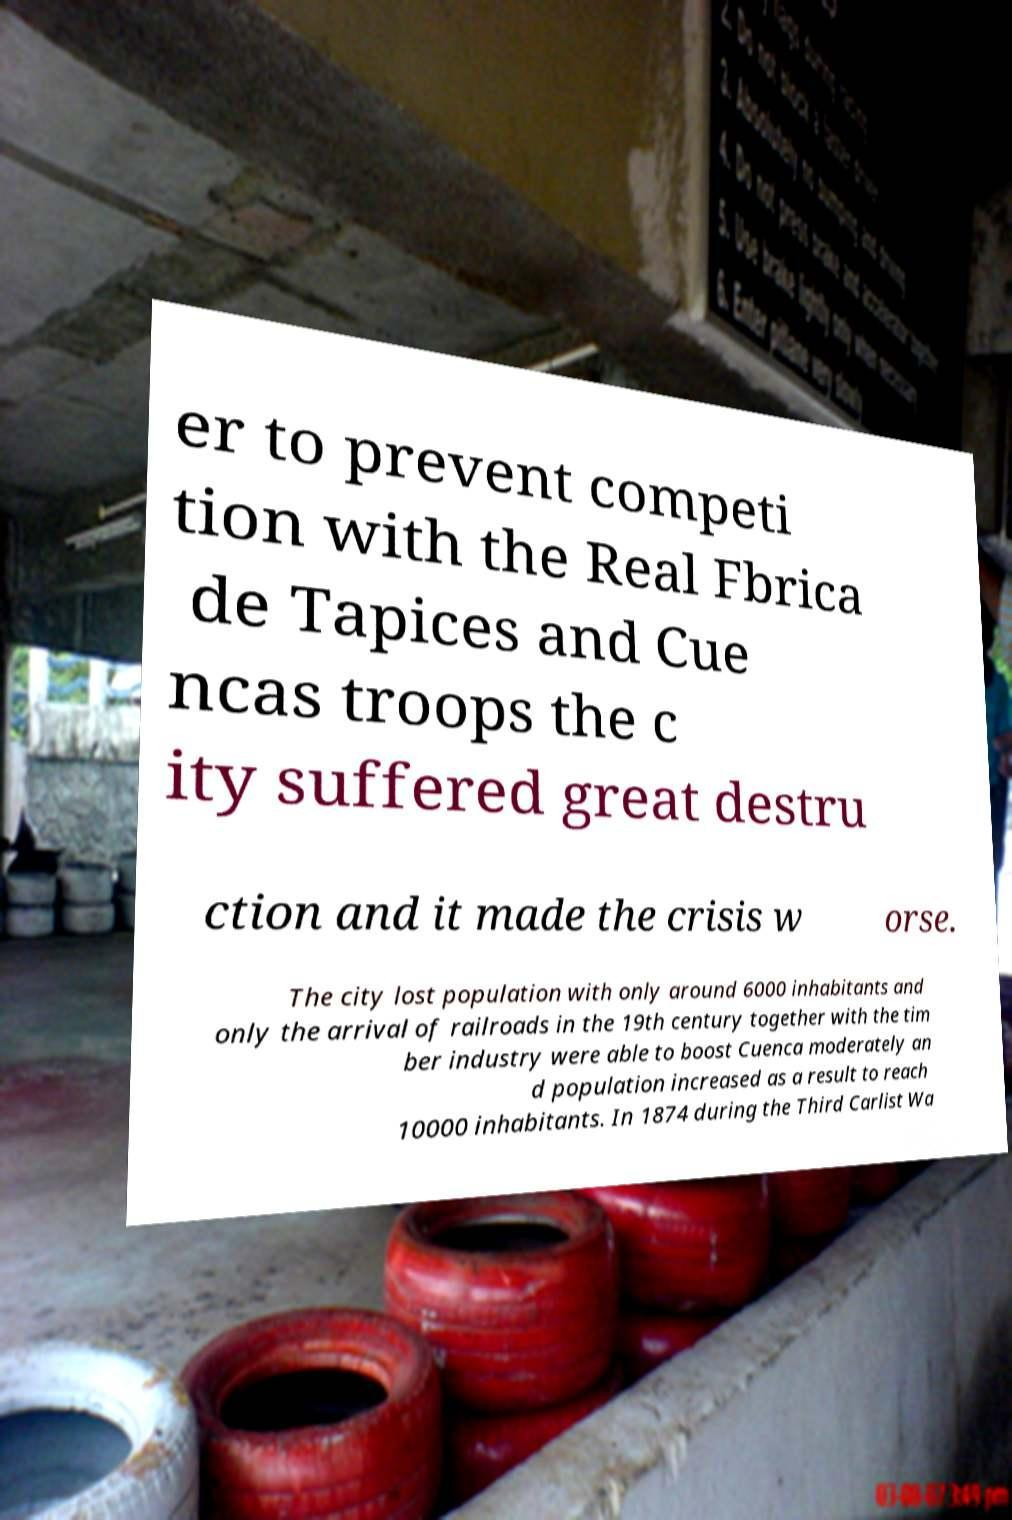Could you assist in decoding the text presented in this image and type it out clearly? er to prevent competi tion with the Real Fbrica de Tapices and Cue ncas troops the c ity suffered great destru ction and it made the crisis w orse. The city lost population with only around 6000 inhabitants and only the arrival of railroads in the 19th century together with the tim ber industry were able to boost Cuenca moderately an d population increased as a result to reach 10000 inhabitants. In 1874 during the Third Carlist Wa 